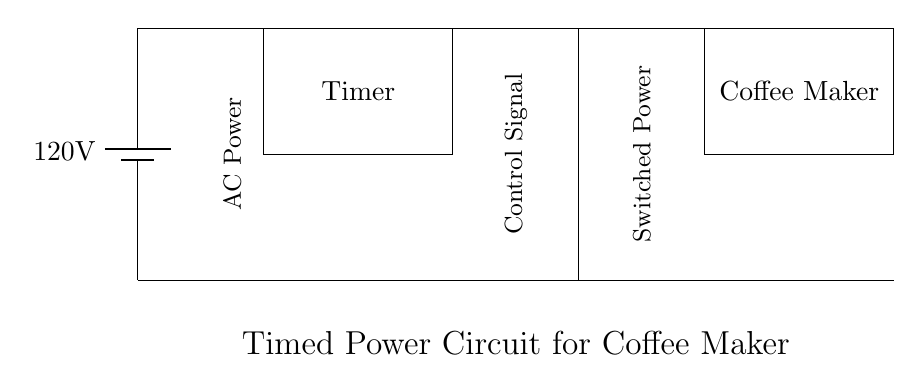What is the voltage supplied by the battery? The circuit diagram shows a battery labeled with a voltage of 120V, which indicates the supply voltage for the circuit.
Answer: 120V What component controls the timing for the coffee maker? The diagram includes a rectangle labeled "Timer," which is responsible for controlling when the coffee maker is powered on.
Answer: Timer How many main components are present in the circuit? Examining the circuit, we can identify three main components: the battery, the timer, the relay, and the coffee maker. Thus, the total is four.
Answer: Four What type of signal does the relay receive? As per the diagram, the relay is connected to the timer, which provides a control signal. Therefore, the signal received is defined as the control signal.
Answer: Control signal What happens to the power when the timer activates? The timer, when it activates, sends a signal to the relay, which then allows power to flow to the coffee maker, effectively turning it on.
Answer: Power flows to coffee maker What is the purpose of the relay in this circuit? The relay serves as a switch that controls the connection between the timer and the coffee maker, making it possible to control the power based on the timer's settings.
Answer: Control switch 